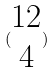<formula> <loc_0><loc_0><loc_500><loc_500>( \begin{matrix} 1 2 \\ 4 \end{matrix} )</formula> 